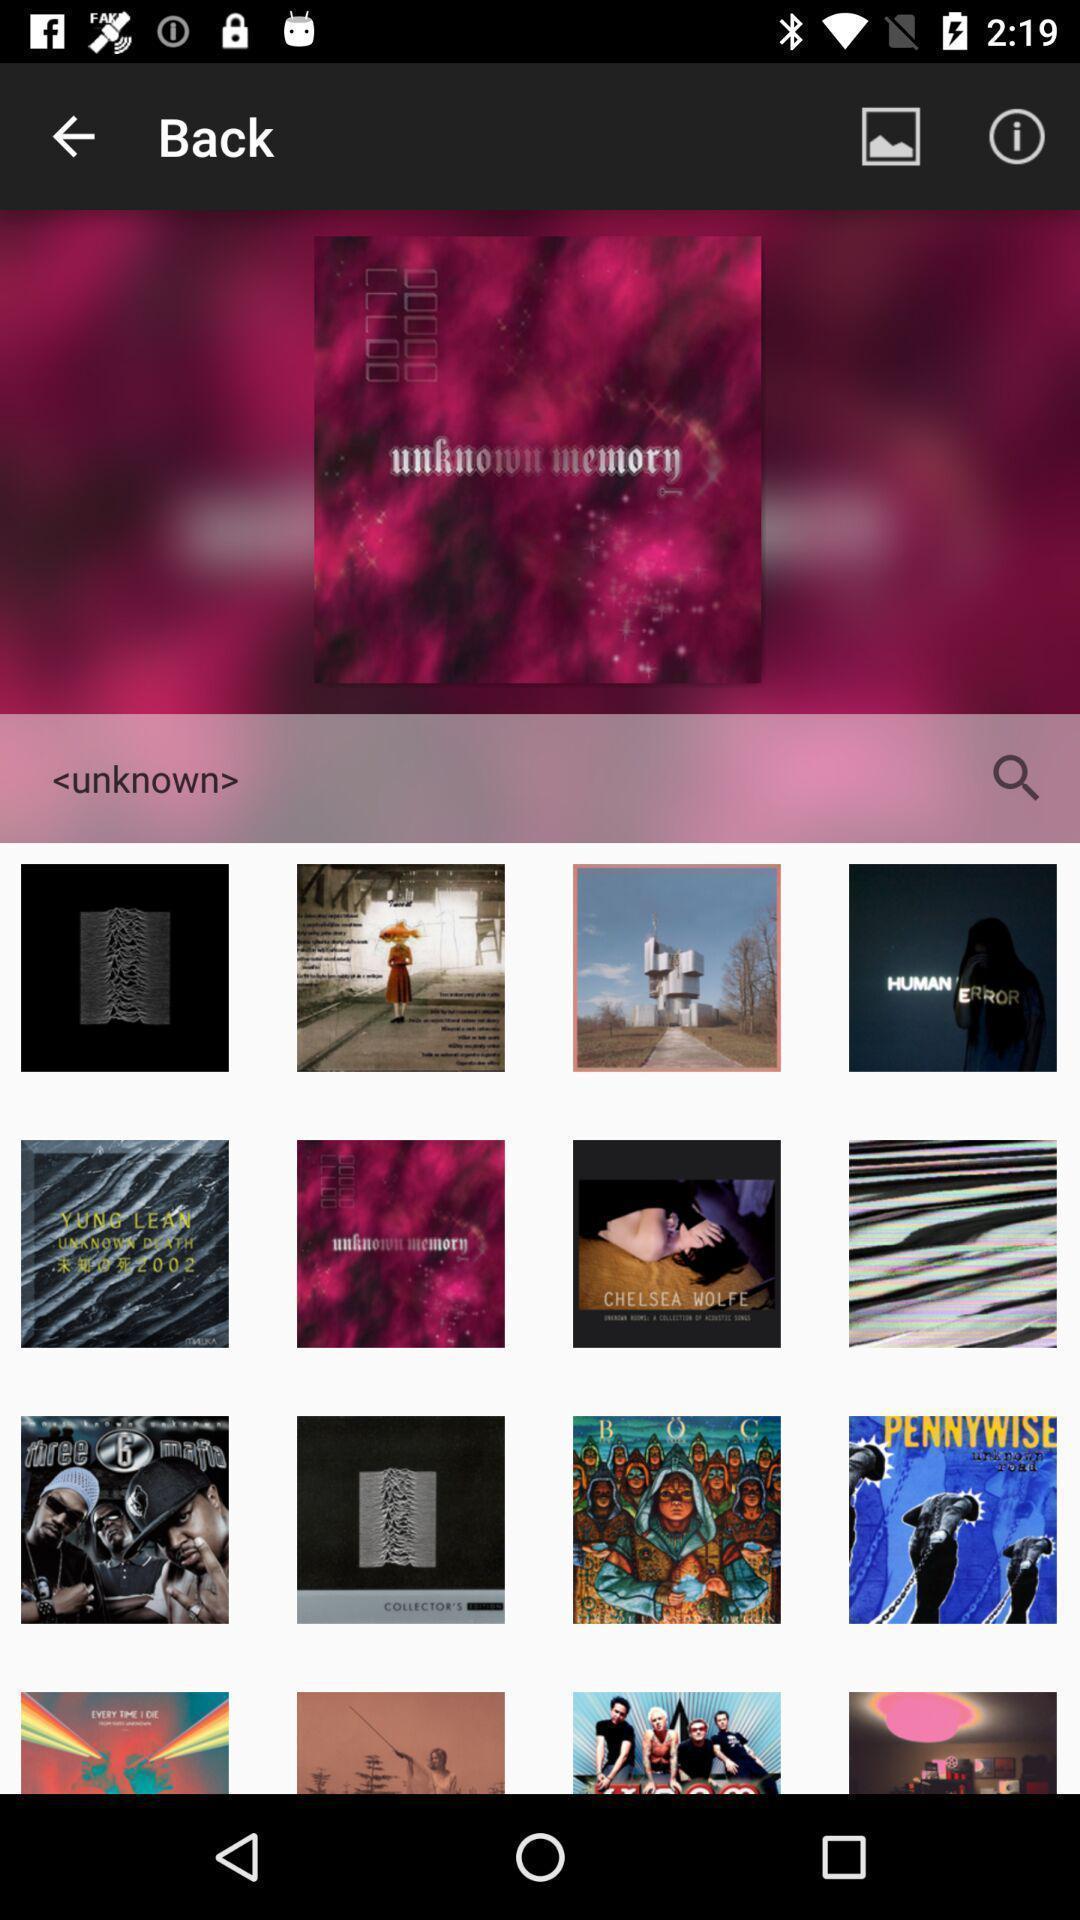What details can you identify in this image? Search results for album arts. 